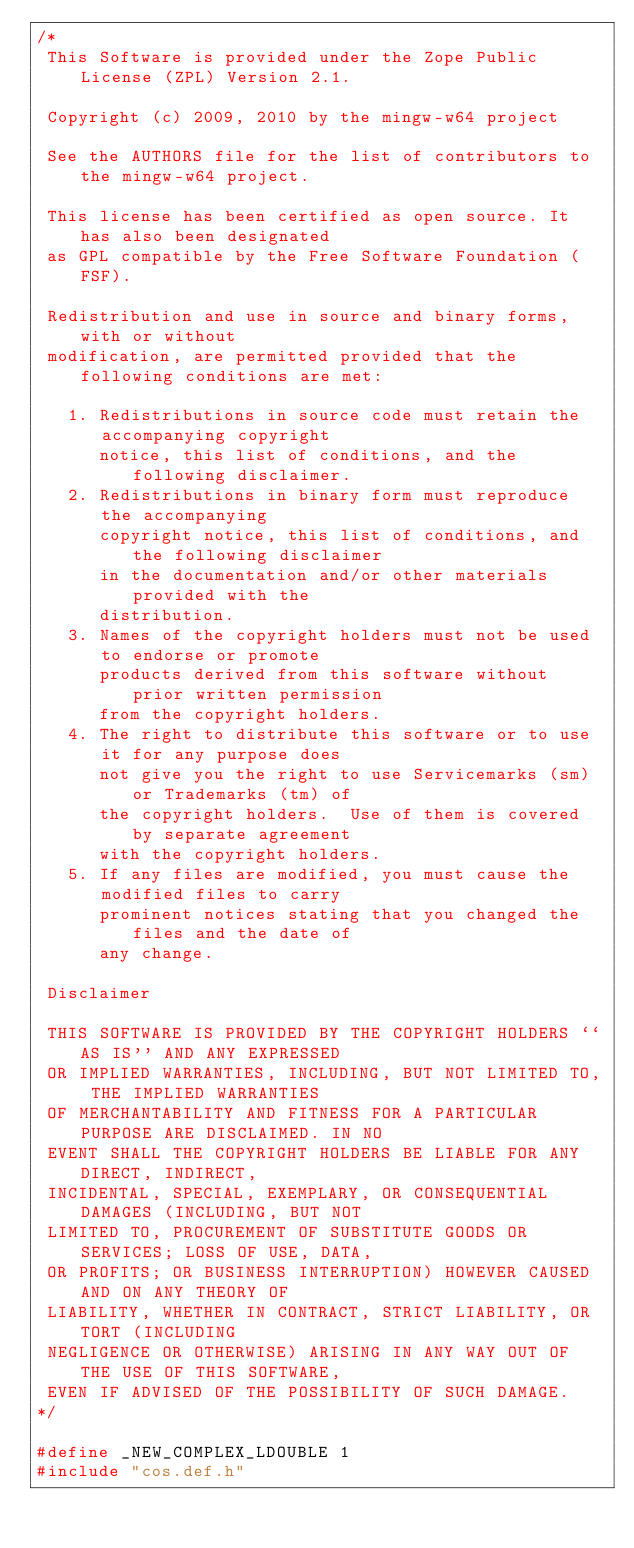<code> <loc_0><loc_0><loc_500><loc_500><_C_>/*
 This Software is provided under the Zope Public License (ZPL) Version 2.1.

 Copyright (c) 2009, 2010 by the mingw-w64 project

 See the AUTHORS file for the list of contributors to the mingw-w64 project.

 This license has been certified as open source. It has also been designated
 as GPL compatible by the Free Software Foundation (FSF).

 Redistribution and use in source and binary forms, with or without
 modification, are permitted provided that the following conditions are met:

   1. Redistributions in source code must retain the accompanying copyright
      notice, this list of conditions, and the following disclaimer.
   2. Redistributions in binary form must reproduce the accompanying
      copyright notice, this list of conditions, and the following disclaimer
      in the documentation and/or other materials provided with the
      distribution.
   3. Names of the copyright holders must not be used to endorse or promote
      products derived from this software without prior written permission
      from the copyright holders.
   4. The right to distribute this software or to use it for any purpose does
      not give you the right to use Servicemarks (sm) or Trademarks (tm) of
      the copyright holders.  Use of them is covered by separate agreement
      with the copyright holders.
   5. If any files are modified, you must cause the modified files to carry
      prominent notices stating that you changed the files and the date of
      any change.

 Disclaimer

 THIS SOFTWARE IS PROVIDED BY THE COPYRIGHT HOLDERS ``AS IS'' AND ANY EXPRESSED
 OR IMPLIED WARRANTIES, INCLUDING, BUT NOT LIMITED TO, THE IMPLIED WARRANTIES
 OF MERCHANTABILITY AND FITNESS FOR A PARTICULAR PURPOSE ARE DISCLAIMED. IN NO
 EVENT SHALL THE COPYRIGHT HOLDERS BE LIABLE FOR ANY DIRECT, INDIRECT,
 INCIDENTAL, SPECIAL, EXEMPLARY, OR CONSEQUENTIAL DAMAGES (INCLUDING, BUT NOT
 LIMITED TO, PROCUREMENT OF SUBSTITUTE GOODS OR SERVICES; LOSS OF USE, DATA, 
 OR PROFITS; OR BUSINESS INTERRUPTION) HOWEVER CAUSED AND ON ANY THEORY OF
 LIABILITY, WHETHER IN CONTRACT, STRICT LIABILITY, OR TORT (INCLUDING
 NEGLIGENCE OR OTHERWISE) ARISING IN ANY WAY OUT OF THE USE OF THIS SOFTWARE,
 EVEN IF ADVISED OF THE POSSIBILITY OF SUCH DAMAGE.
*/

#define _NEW_COMPLEX_LDOUBLE 1
#include "cos.def.h"
</code> 